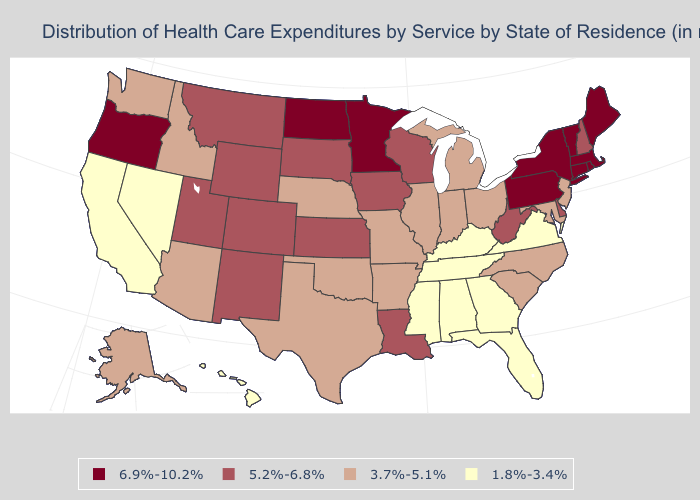Does Kansas have the highest value in the MidWest?
Concise answer only. No. Name the states that have a value in the range 5.2%-6.8%?
Keep it brief. Colorado, Delaware, Iowa, Kansas, Louisiana, Montana, New Hampshire, New Mexico, South Dakota, Utah, West Virginia, Wisconsin, Wyoming. Name the states that have a value in the range 3.7%-5.1%?
Quick response, please. Alaska, Arizona, Arkansas, Idaho, Illinois, Indiana, Maryland, Michigan, Missouri, Nebraska, New Jersey, North Carolina, Ohio, Oklahoma, South Carolina, Texas, Washington. Does Montana have a lower value than Oregon?
Keep it brief. Yes. Which states have the highest value in the USA?
Concise answer only. Connecticut, Maine, Massachusetts, Minnesota, New York, North Dakota, Oregon, Pennsylvania, Rhode Island, Vermont. Which states have the highest value in the USA?
Concise answer only. Connecticut, Maine, Massachusetts, Minnesota, New York, North Dakota, Oregon, Pennsylvania, Rhode Island, Vermont. Does California have the highest value in the USA?
Answer briefly. No. What is the value of Ohio?
Keep it brief. 3.7%-5.1%. Does the first symbol in the legend represent the smallest category?
Answer briefly. No. Does the first symbol in the legend represent the smallest category?
Concise answer only. No. What is the value of Massachusetts?
Write a very short answer. 6.9%-10.2%. Among the states that border Iowa , does Illinois have the lowest value?
Answer briefly. Yes. Name the states that have a value in the range 1.8%-3.4%?
Be succinct. Alabama, California, Florida, Georgia, Hawaii, Kentucky, Mississippi, Nevada, Tennessee, Virginia. Does Kentucky have a lower value than Alabama?
Be succinct. No. What is the lowest value in states that border New Mexico?
Short answer required. 3.7%-5.1%. 